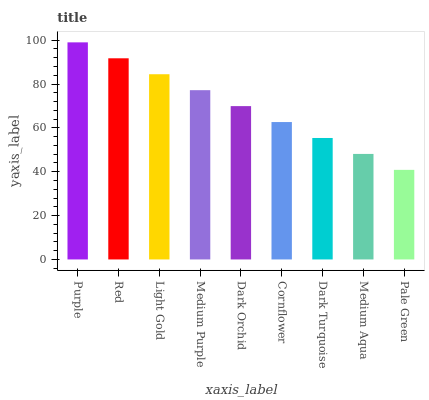Is Red the minimum?
Answer yes or no. No. Is Red the maximum?
Answer yes or no. No. Is Purple greater than Red?
Answer yes or no. Yes. Is Red less than Purple?
Answer yes or no. Yes. Is Red greater than Purple?
Answer yes or no. No. Is Purple less than Red?
Answer yes or no. No. Is Dark Orchid the high median?
Answer yes or no. Yes. Is Dark Orchid the low median?
Answer yes or no. Yes. Is Light Gold the high median?
Answer yes or no. No. Is Medium Purple the low median?
Answer yes or no. No. 